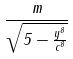<formula> <loc_0><loc_0><loc_500><loc_500>\frac { m } { \sqrt { 5 - \frac { y ^ { 8 } } { c ^ { 8 } } } }</formula> 